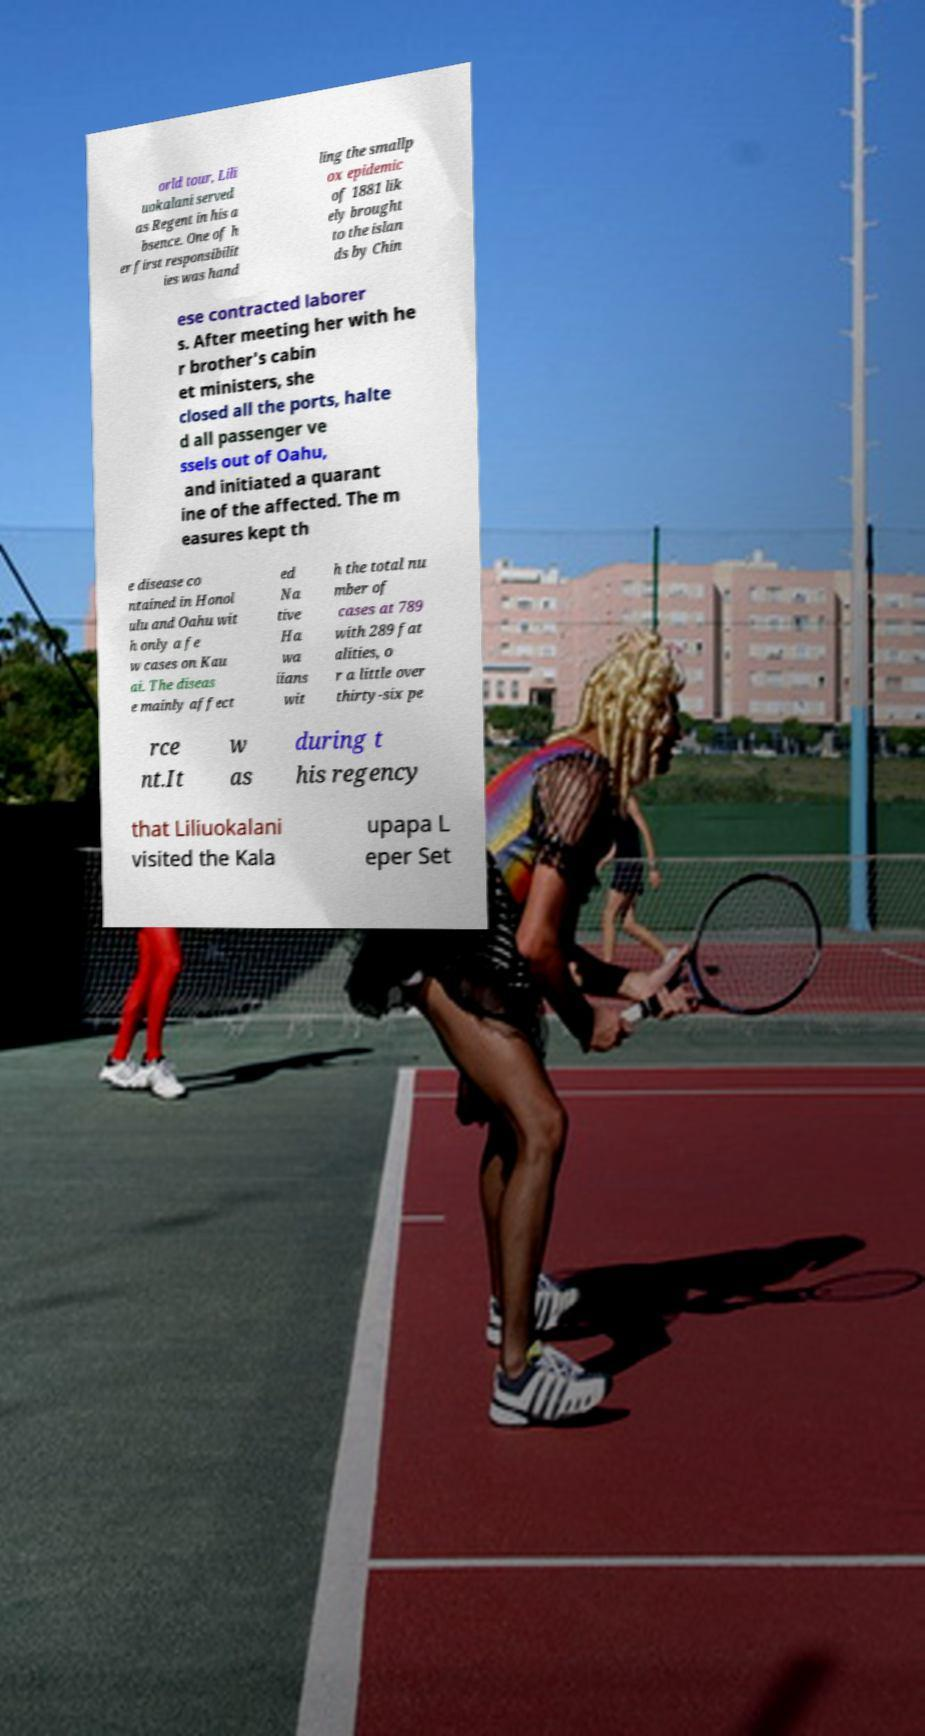There's text embedded in this image that I need extracted. Can you transcribe it verbatim? orld tour, Lili uokalani served as Regent in his a bsence. One of h er first responsibilit ies was hand ling the smallp ox epidemic of 1881 lik ely brought to the islan ds by Chin ese contracted laborer s. After meeting her with he r brother's cabin et ministers, she closed all the ports, halte d all passenger ve ssels out of Oahu, and initiated a quarant ine of the affected. The m easures kept th e disease co ntained in Honol ulu and Oahu wit h only a fe w cases on Kau ai. The diseas e mainly affect ed Na tive Ha wa iians wit h the total nu mber of cases at 789 with 289 fat alities, o r a little over thirty-six pe rce nt.It w as during t his regency that Liliuokalani visited the Kala upapa L eper Set 